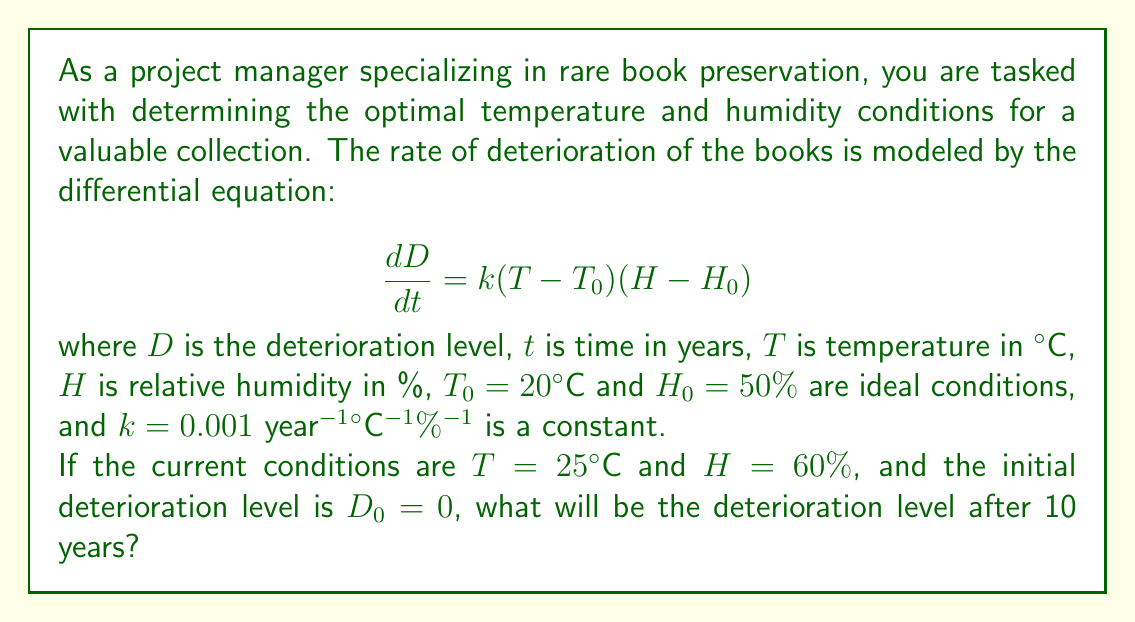Teach me how to tackle this problem. To solve this problem, we need to integrate the given differential equation:

1) First, let's substitute the given values into the equation:
   $$\frac{dD}{dt} = 0.001(25 - 20)(60 - 50) = 0.001 \cdot 5 \cdot 10 = 0.05$$

2) This means the rate of deterioration is constant under these conditions. We can integrate both sides with respect to time:
   $$\int_{0}^{10} dD = \int_{0}^{10} 0.05 dt$$

3) Solving the integral:
   $$D - D_0 = 0.05t|_{0}^{10}$$

4) Substituting the limits:
   $$D - 0 = 0.05 \cdot 10$$

5) Simplifying:
   $$D = 0.5$$

Therefore, after 10 years, the deterioration level will be 0.5 units.
Answer: The deterioration level after 10 years will be 0.5 units. 